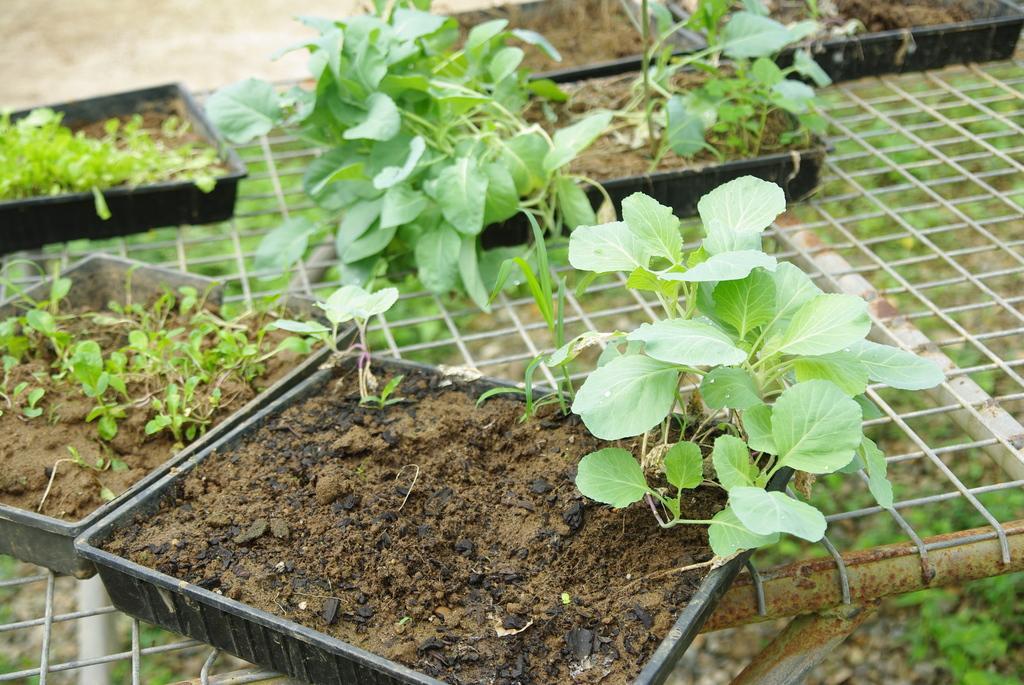In one or two sentences, can you explain what this image depicts? There are plants on the mud which is on the black color trays. And these trays on the net. In the background, there are plants on the ground. 